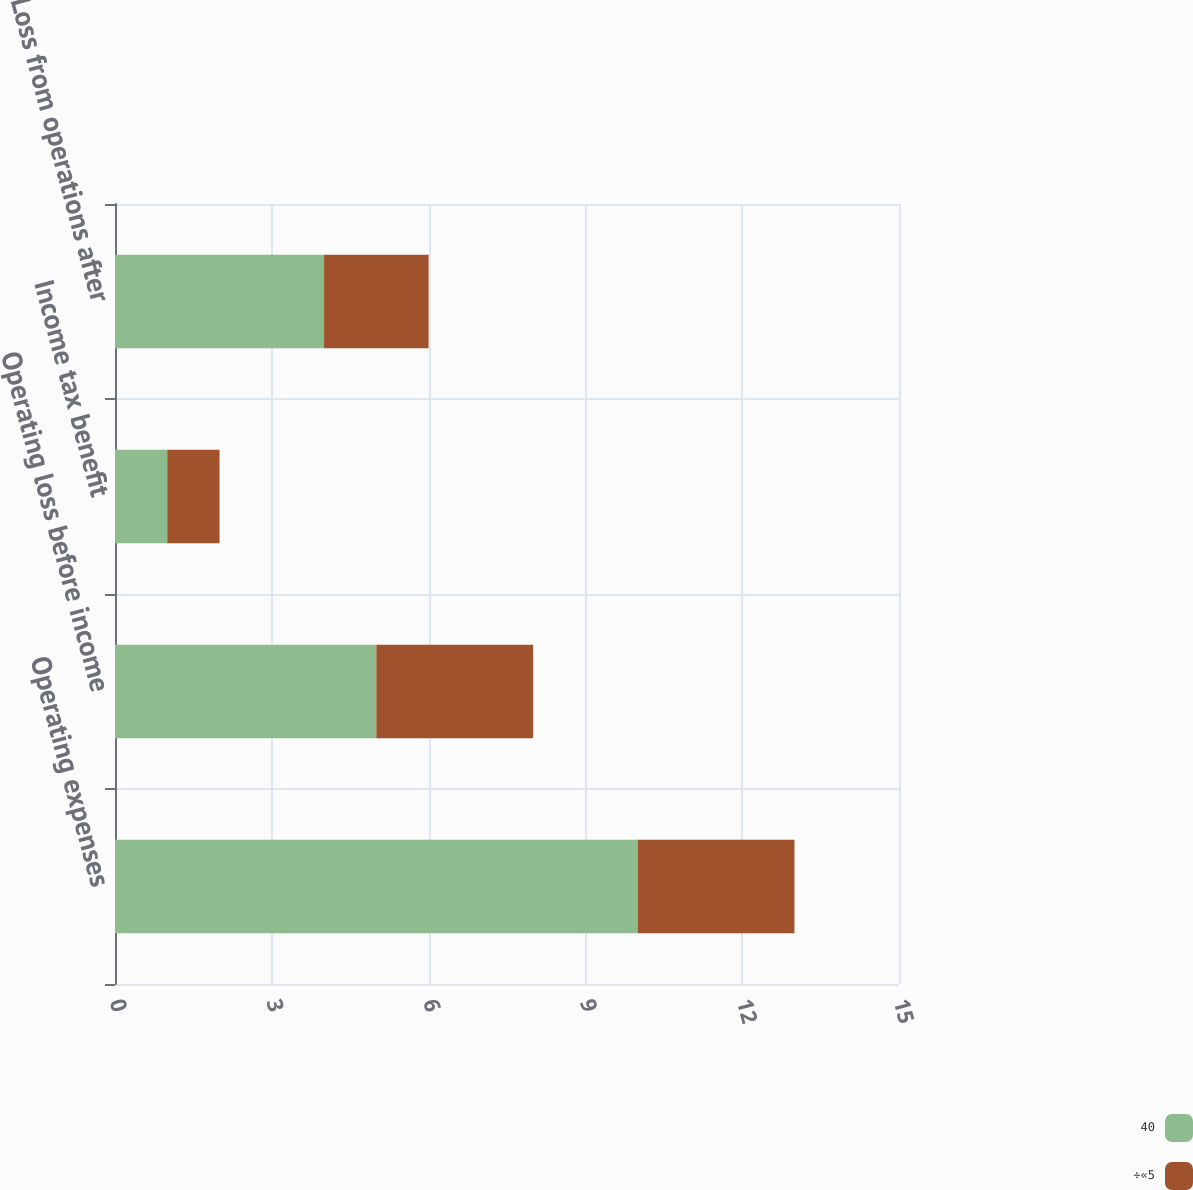<chart> <loc_0><loc_0><loc_500><loc_500><stacked_bar_chart><ecel><fcel>Operating expenses<fcel>Operating loss before income<fcel>Income tax benefit<fcel>Loss from operations after<nl><fcel>40<fcel>10<fcel>5<fcel>1<fcel>4<nl><fcel>÷«5<fcel>3<fcel>3<fcel>1<fcel>2<nl></chart> 